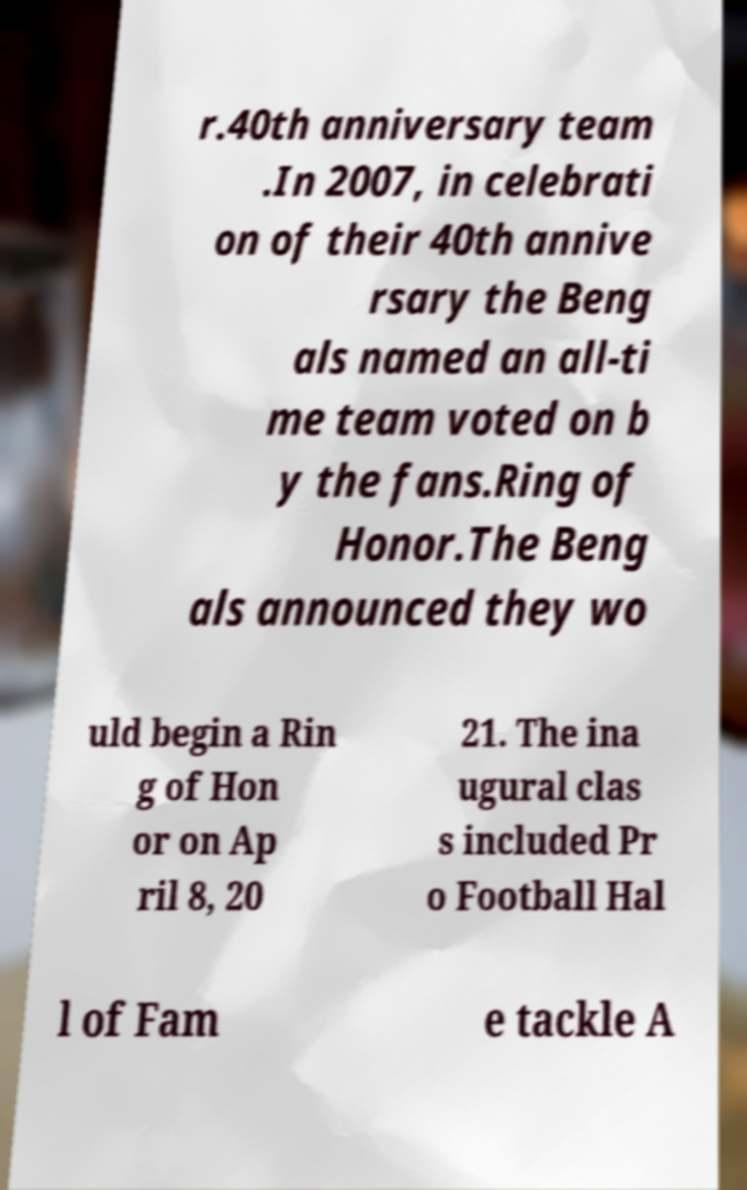Can you accurately transcribe the text from the provided image for me? r.40th anniversary team .In 2007, in celebrati on of their 40th annive rsary the Beng als named an all-ti me team voted on b y the fans.Ring of Honor.The Beng als announced they wo uld begin a Rin g of Hon or on Ap ril 8, 20 21. The ina ugural clas s included Pr o Football Hal l of Fam e tackle A 